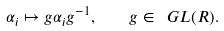Convert formula to latex. <formula><loc_0><loc_0><loc_500><loc_500>\alpha _ { i } \mapsto g \alpha _ { i } g ^ { - 1 } , \quad g \in \ G L ( R ) .</formula> 